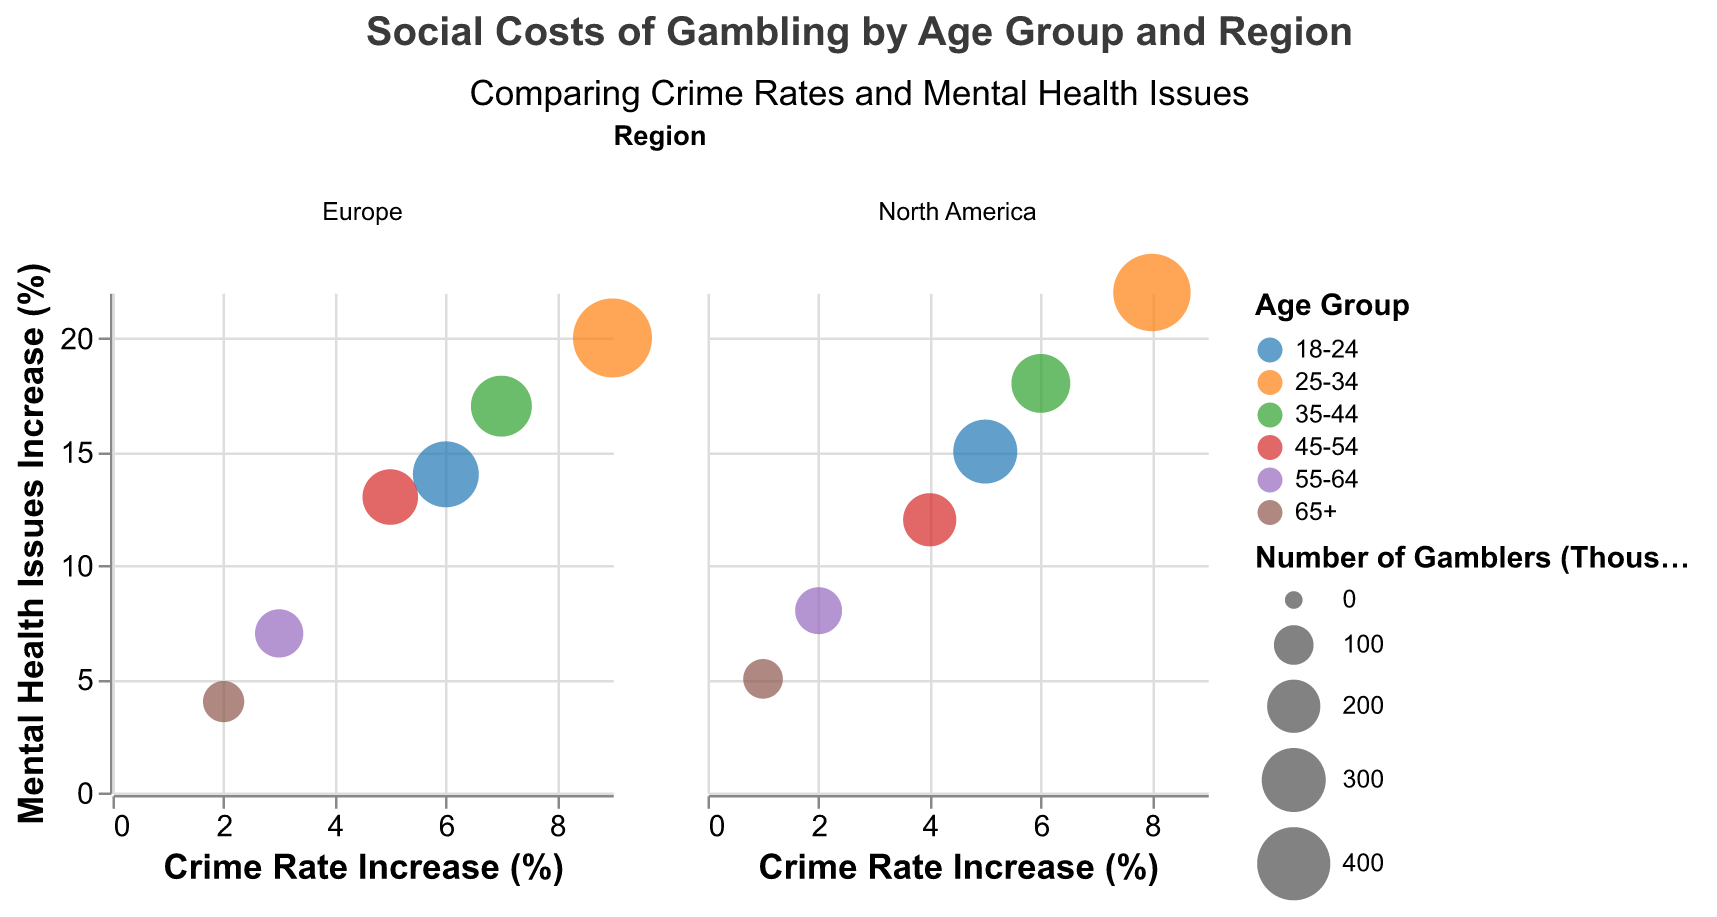What is the title of the subplot? The title is displayed at the top of the subplot. It reads "Social Costs of Gambling by Age Group and Region".
Answer: Social Costs of Gambling by Age Group and Region What does the x-axis represent? The x-axis label indicates that it represents "Crime Rate Increase (%)".
Answer: Crime Rate Increase (%) Which age group has the highest increase in mental health issues in North America? By looking at the y-axis, you can see the highest position on the North America subplot. The 25-34 age group has the highest increase (22%).
Answer: 25-34 How does the crime rate increase for the 55-64 age group in Europe compare with North America? Compare the crime rate increase for 55-64 age group in both subplots. In Europe, it's 3%, while in North America, it's 2%.
Answer: Higher in Europe What is the primary color used for the 18-24 age group? The color legend indicates the primary color for each age group. The 18-24 age group is represented by the first color in the category10 scheme (usually blue).
Answer: Blue Which region has a higher overall crime rate increase for the 25-34 age group? Compare the bubble position of the 25-34 age group in both subplots on the x-axis. Europe shows a higher increase (9%) compared to North America (8%).
Answer: Europe How many gamblers are represented by the largest circle in the North America subplot? The size legend indicates the number of gamblers. The largest circle in the North America subplot represents 450,000 gamblers, which corresponds to the 25-34 age group.
Answer: 450,000 What age group in Europe shows both the lowest crime rate and mental health issues increase? Locate the smallest x and y values point within the Europe subplot, corresponding to the 65+ age group (2% crime rate increase, 4% mental health issues increase).
Answer: 65+ 